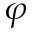Convert formula to latex. <formula><loc_0><loc_0><loc_500><loc_500>\varphi</formula> 